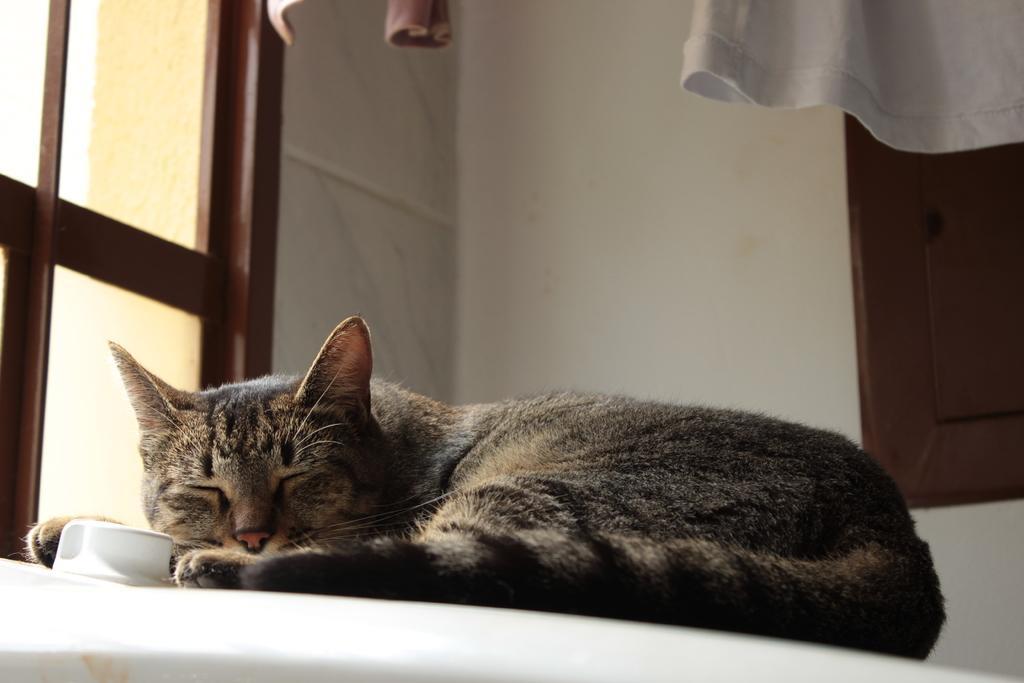Can you describe this image briefly? In the center of the image a cat is present. At the top of the image we can see a wall, cloths, windows are there. 